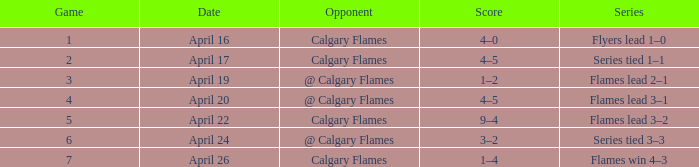Which Date has a Score of 4–5, and a Game smaller than 4? April 17. 